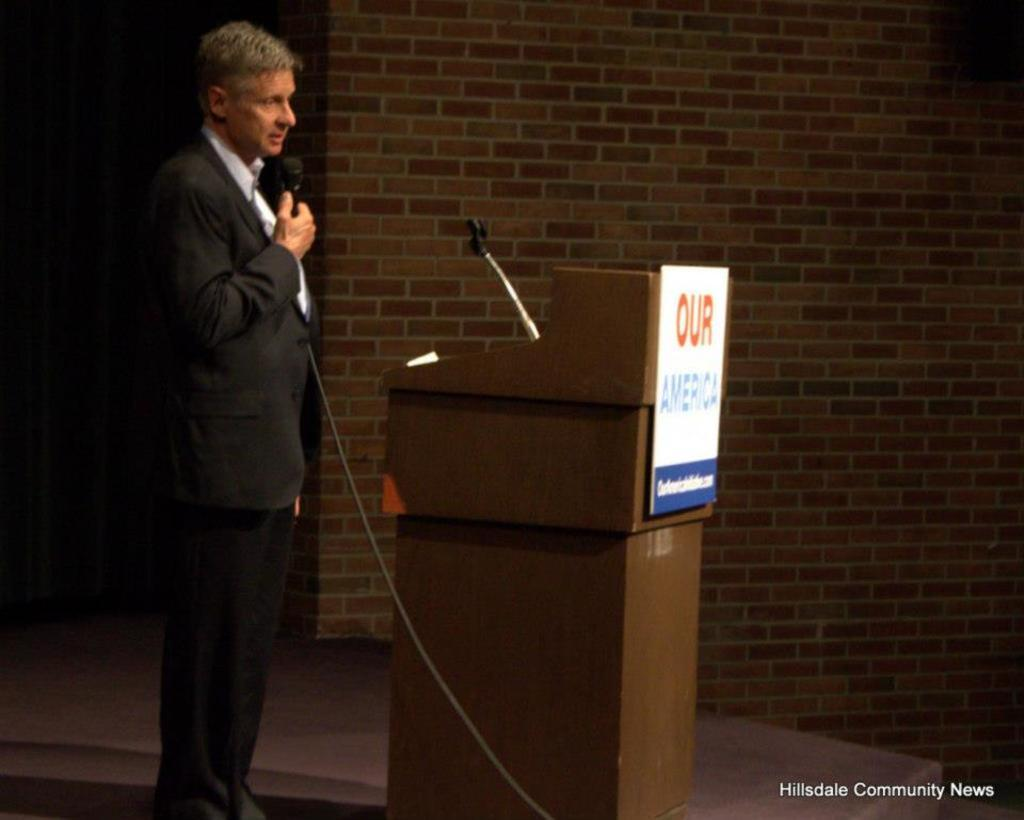<image>
Render a clear and concise summary of the photo. A man at a podium speaking behind a sign that says Our America. 